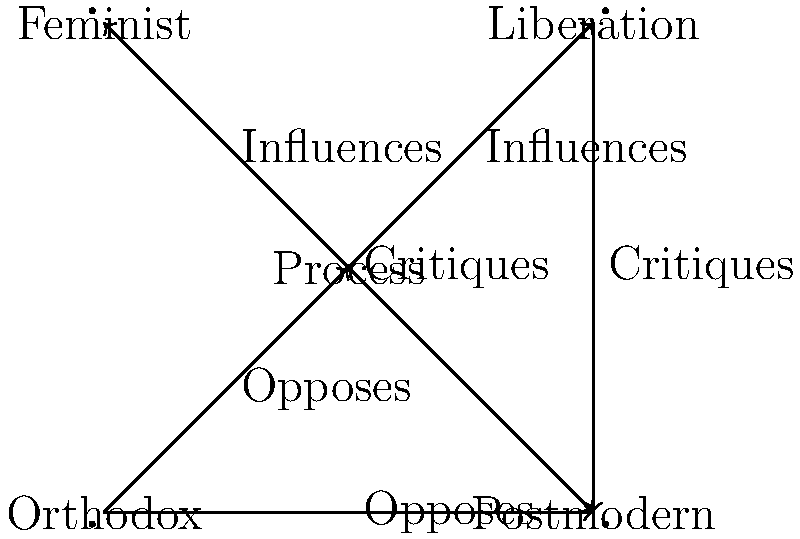Based on the network diagram of theological schools, which school of thought seems to be the most isolated, having only outgoing connections and no incoming influences? To answer this question, we need to analyze the connections between the different schools of thought represented in the network diagram:

1. Process Theology:
   - Outgoing: Influences Liberation Theology and Feminist Theology
   - Incoming: Opposed by Orthodox Theology

2. Liberation Theology:
   - Outgoing: Critiques Postmodern Theology
   - Incoming: Influenced by Process Theology

3. Feminist Theology:
   - Outgoing: Critiques Postmodern Theology
   - Incoming: Influenced by Process Theology

4. Orthodox Theology:
   - Outgoing: Opposes Process Theology and Postmodern Theology
   - Incoming: None

5. Postmodern Theology:
   - Outgoing: None
   - Incoming: Critiqued by Liberation Theology and Feminist Theology, Opposed by Orthodox Theology

Analyzing these connections, we can see that Orthodox Theology is the only school of thought that has only outgoing connections (opposing Process and Postmodern Theology) and no incoming influences or critiques from other schools.
Answer: Orthodox Theology 